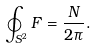Convert formula to latex. <formula><loc_0><loc_0><loc_500><loc_500>\oint _ { S ^ { 2 } } F = \frac { N } { 2 \pi } .</formula> 